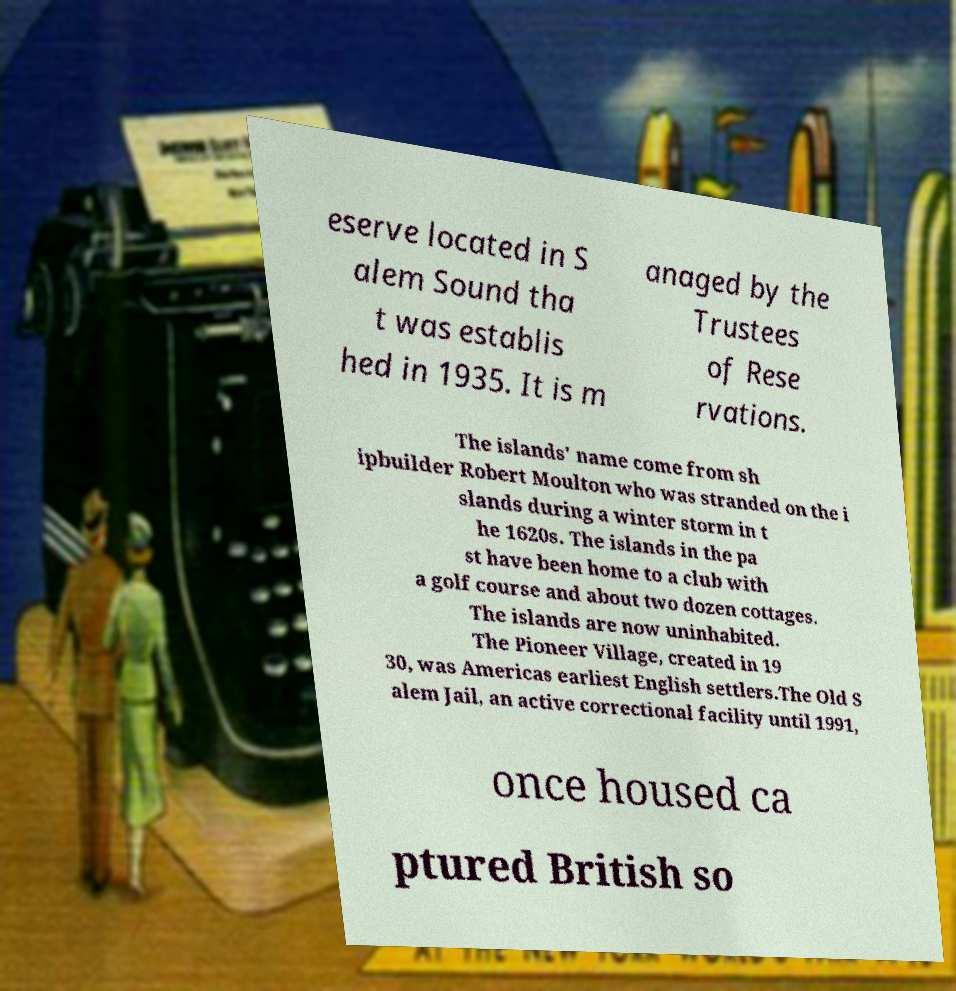Could you extract and type out the text from this image? eserve located in S alem Sound tha t was establis hed in 1935. It is m anaged by the Trustees of Rese rvations. The islands' name come from sh ipbuilder Robert Moulton who was stranded on the i slands during a winter storm in t he 1620s. The islands in the pa st have been home to a club with a golf course and about two dozen cottages. The islands are now uninhabited. The Pioneer Village, created in 19 30, was Americas earliest English settlers.The Old S alem Jail, an active correctional facility until 1991, once housed ca ptured British so 